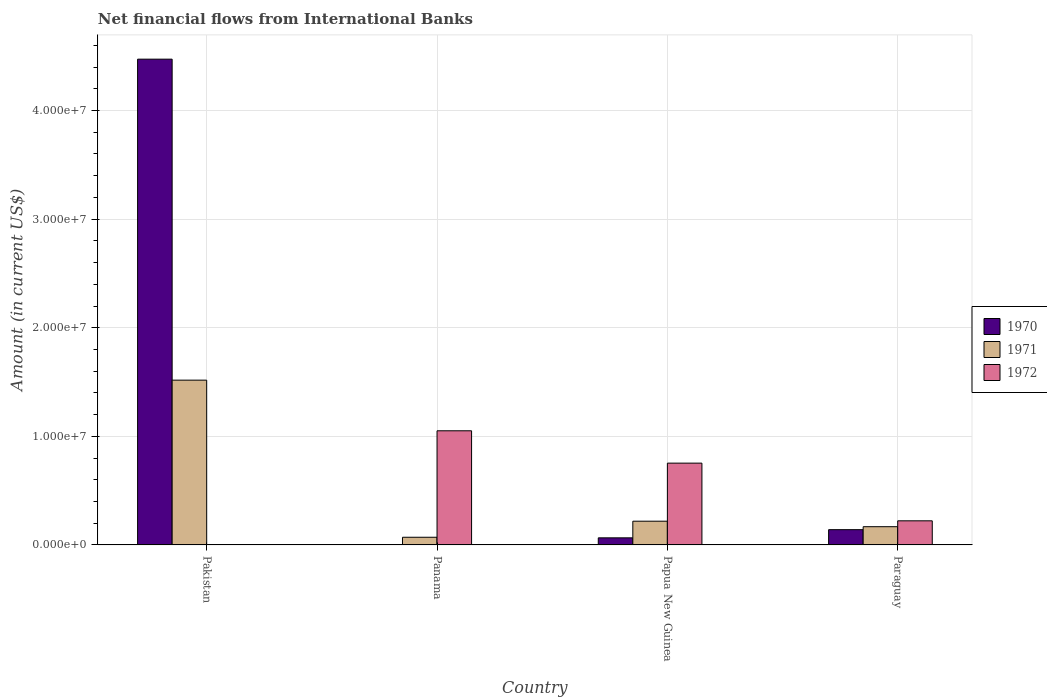Are the number of bars per tick equal to the number of legend labels?
Your answer should be compact. No. How many bars are there on the 2nd tick from the right?
Your answer should be compact. 3. What is the label of the 3rd group of bars from the left?
Your response must be concise. Papua New Guinea. What is the net financial aid flows in 1970 in Paraguay?
Offer a very short reply. 1.41e+06. Across all countries, what is the maximum net financial aid flows in 1971?
Keep it short and to the point. 1.52e+07. Across all countries, what is the minimum net financial aid flows in 1972?
Offer a terse response. 0. In which country was the net financial aid flows in 1972 maximum?
Ensure brevity in your answer.  Panama. What is the total net financial aid flows in 1970 in the graph?
Offer a very short reply. 4.68e+07. What is the difference between the net financial aid flows in 1972 in Panama and that in Paraguay?
Keep it short and to the point. 8.29e+06. What is the difference between the net financial aid flows in 1970 in Pakistan and the net financial aid flows in 1972 in Panama?
Your answer should be compact. 3.42e+07. What is the average net financial aid flows in 1972 per country?
Your answer should be very brief. 5.07e+06. What is the difference between the net financial aid flows of/in 1972 and net financial aid flows of/in 1971 in Panama?
Your response must be concise. 9.80e+06. What is the ratio of the net financial aid flows in 1971 in Pakistan to that in Panama?
Give a very brief answer. 21.46. Is the net financial aid flows in 1970 in Pakistan less than that in Paraguay?
Offer a terse response. No. Is the difference between the net financial aid flows in 1972 in Panama and Papua New Guinea greater than the difference between the net financial aid flows in 1971 in Panama and Papua New Guinea?
Provide a succinct answer. Yes. What is the difference between the highest and the second highest net financial aid flows in 1971?
Offer a very short reply. 1.30e+07. What is the difference between the highest and the lowest net financial aid flows in 1971?
Offer a terse response. 1.45e+07. In how many countries, is the net financial aid flows in 1971 greater than the average net financial aid flows in 1971 taken over all countries?
Provide a short and direct response. 1. Is it the case that in every country, the sum of the net financial aid flows in 1971 and net financial aid flows in 1972 is greater than the net financial aid flows in 1970?
Provide a short and direct response. No. How many bars are there?
Your response must be concise. 10. Are all the bars in the graph horizontal?
Give a very brief answer. No. How many countries are there in the graph?
Offer a very short reply. 4. Are the values on the major ticks of Y-axis written in scientific E-notation?
Provide a short and direct response. Yes. How many legend labels are there?
Provide a short and direct response. 3. How are the legend labels stacked?
Your response must be concise. Vertical. What is the title of the graph?
Provide a succinct answer. Net financial flows from International Banks. Does "1970" appear as one of the legend labels in the graph?
Offer a terse response. Yes. What is the label or title of the X-axis?
Ensure brevity in your answer.  Country. What is the Amount (in current US$) of 1970 in Pakistan?
Offer a terse response. 4.47e+07. What is the Amount (in current US$) of 1971 in Pakistan?
Your answer should be very brief. 1.52e+07. What is the Amount (in current US$) of 1972 in Pakistan?
Your answer should be very brief. 0. What is the Amount (in current US$) in 1971 in Panama?
Offer a very short reply. 7.07e+05. What is the Amount (in current US$) of 1972 in Panama?
Provide a short and direct response. 1.05e+07. What is the Amount (in current US$) in 1970 in Papua New Guinea?
Offer a terse response. 6.53e+05. What is the Amount (in current US$) of 1971 in Papua New Guinea?
Your answer should be very brief. 2.18e+06. What is the Amount (in current US$) in 1972 in Papua New Guinea?
Ensure brevity in your answer.  7.53e+06. What is the Amount (in current US$) in 1970 in Paraguay?
Give a very brief answer. 1.41e+06. What is the Amount (in current US$) of 1971 in Paraguay?
Keep it short and to the point. 1.68e+06. What is the Amount (in current US$) of 1972 in Paraguay?
Give a very brief answer. 2.22e+06. Across all countries, what is the maximum Amount (in current US$) of 1970?
Ensure brevity in your answer.  4.47e+07. Across all countries, what is the maximum Amount (in current US$) of 1971?
Provide a succinct answer. 1.52e+07. Across all countries, what is the maximum Amount (in current US$) of 1972?
Your answer should be very brief. 1.05e+07. Across all countries, what is the minimum Amount (in current US$) of 1971?
Provide a succinct answer. 7.07e+05. Across all countries, what is the minimum Amount (in current US$) of 1972?
Make the answer very short. 0. What is the total Amount (in current US$) of 1970 in the graph?
Provide a succinct answer. 4.68e+07. What is the total Amount (in current US$) in 1971 in the graph?
Give a very brief answer. 1.97e+07. What is the total Amount (in current US$) in 1972 in the graph?
Provide a short and direct response. 2.03e+07. What is the difference between the Amount (in current US$) in 1971 in Pakistan and that in Panama?
Keep it short and to the point. 1.45e+07. What is the difference between the Amount (in current US$) of 1970 in Pakistan and that in Papua New Guinea?
Give a very brief answer. 4.41e+07. What is the difference between the Amount (in current US$) in 1971 in Pakistan and that in Papua New Guinea?
Ensure brevity in your answer.  1.30e+07. What is the difference between the Amount (in current US$) of 1970 in Pakistan and that in Paraguay?
Give a very brief answer. 4.33e+07. What is the difference between the Amount (in current US$) of 1971 in Pakistan and that in Paraguay?
Your answer should be very brief. 1.35e+07. What is the difference between the Amount (in current US$) of 1971 in Panama and that in Papua New Guinea?
Provide a short and direct response. -1.48e+06. What is the difference between the Amount (in current US$) of 1972 in Panama and that in Papua New Guinea?
Keep it short and to the point. 2.98e+06. What is the difference between the Amount (in current US$) of 1971 in Panama and that in Paraguay?
Your response must be concise. -9.72e+05. What is the difference between the Amount (in current US$) in 1972 in Panama and that in Paraguay?
Your answer should be very brief. 8.29e+06. What is the difference between the Amount (in current US$) in 1970 in Papua New Guinea and that in Paraguay?
Your answer should be compact. -7.53e+05. What is the difference between the Amount (in current US$) of 1971 in Papua New Guinea and that in Paraguay?
Give a very brief answer. 5.06e+05. What is the difference between the Amount (in current US$) of 1972 in Papua New Guinea and that in Paraguay?
Offer a terse response. 5.31e+06. What is the difference between the Amount (in current US$) in 1970 in Pakistan and the Amount (in current US$) in 1971 in Panama?
Offer a terse response. 4.40e+07. What is the difference between the Amount (in current US$) in 1970 in Pakistan and the Amount (in current US$) in 1972 in Panama?
Make the answer very short. 3.42e+07. What is the difference between the Amount (in current US$) of 1971 in Pakistan and the Amount (in current US$) of 1972 in Panama?
Offer a terse response. 4.66e+06. What is the difference between the Amount (in current US$) in 1970 in Pakistan and the Amount (in current US$) in 1971 in Papua New Guinea?
Your answer should be compact. 4.25e+07. What is the difference between the Amount (in current US$) in 1970 in Pakistan and the Amount (in current US$) in 1972 in Papua New Guinea?
Offer a terse response. 3.72e+07. What is the difference between the Amount (in current US$) of 1971 in Pakistan and the Amount (in current US$) of 1972 in Papua New Guinea?
Make the answer very short. 7.64e+06. What is the difference between the Amount (in current US$) of 1970 in Pakistan and the Amount (in current US$) of 1971 in Paraguay?
Offer a very short reply. 4.31e+07. What is the difference between the Amount (in current US$) in 1970 in Pakistan and the Amount (in current US$) in 1972 in Paraguay?
Offer a very short reply. 4.25e+07. What is the difference between the Amount (in current US$) of 1971 in Pakistan and the Amount (in current US$) of 1972 in Paraguay?
Make the answer very short. 1.30e+07. What is the difference between the Amount (in current US$) of 1971 in Panama and the Amount (in current US$) of 1972 in Papua New Guinea?
Provide a succinct answer. -6.82e+06. What is the difference between the Amount (in current US$) in 1971 in Panama and the Amount (in current US$) in 1972 in Paraguay?
Make the answer very short. -1.51e+06. What is the difference between the Amount (in current US$) of 1970 in Papua New Guinea and the Amount (in current US$) of 1971 in Paraguay?
Your answer should be compact. -1.03e+06. What is the difference between the Amount (in current US$) of 1970 in Papua New Guinea and the Amount (in current US$) of 1972 in Paraguay?
Offer a very short reply. -1.57e+06. What is the difference between the Amount (in current US$) of 1971 in Papua New Guinea and the Amount (in current US$) of 1972 in Paraguay?
Ensure brevity in your answer.  -3.50e+04. What is the average Amount (in current US$) in 1970 per country?
Give a very brief answer. 1.17e+07. What is the average Amount (in current US$) of 1971 per country?
Your answer should be very brief. 4.94e+06. What is the average Amount (in current US$) of 1972 per country?
Give a very brief answer. 5.07e+06. What is the difference between the Amount (in current US$) in 1970 and Amount (in current US$) in 1971 in Pakistan?
Keep it short and to the point. 2.96e+07. What is the difference between the Amount (in current US$) in 1971 and Amount (in current US$) in 1972 in Panama?
Keep it short and to the point. -9.80e+06. What is the difference between the Amount (in current US$) in 1970 and Amount (in current US$) in 1971 in Papua New Guinea?
Your answer should be very brief. -1.53e+06. What is the difference between the Amount (in current US$) of 1970 and Amount (in current US$) of 1972 in Papua New Guinea?
Provide a succinct answer. -6.88e+06. What is the difference between the Amount (in current US$) in 1971 and Amount (in current US$) in 1972 in Papua New Guinea?
Offer a very short reply. -5.35e+06. What is the difference between the Amount (in current US$) in 1970 and Amount (in current US$) in 1971 in Paraguay?
Provide a short and direct response. -2.73e+05. What is the difference between the Amount (in current US$) in 1970 and Amount (in current US$) in 1972 in Paraguay?
Make the answer very short. -8.14e+05. What is the difference between the Amount (in current US$) of 1971 and Amount (in current US$) of 1972 in Paraguay?
Ensure brevity in your answer.  -5.41e+05. What is the ratio of the Amount (in current US$) in 1971 in Pakistan to that in Panama?
Offer a terse response. 21.46. What is the ratio of the Amount (in current US$) of 1970 in Pakistan to that in Papua New Guinea?
Make the answer very short. 68.5. What is the ratio of the Amount (in current US$) of 1971 in Pakistan to that in Papua New Guinea?
Provide a short and direct response. 6.94. What is the ratio of the Amount (in current US$) of 1970 in Pakistan to that in Paraguay?
Offer a very short reply. 31.81. What is the ratio of the Amount (in current US$) of 1971 in Pakistan to that in Paraguay?
Offer a terse response. 9.04. What is the ratio of the Amount (in current US$) in 1971 in Panama to that in Papua New Guinea?
Your answer should be very brief. 0.32. What is the ratio of the Amount (in current US$) in 1972 in Panama to that in Papua New Guinea?
Offer a very short reply. 1.4. What is the ratio of the Amount (in current US$) in 1971 in Panama to that in Paraguay?
Provide a succinct answer. 0.42. What is the ratio of the Amount (in current US$) in 1972 in Panama to that in Paraguay?
Give a very brief answer. 4.73. What is the ratio of the Amount (in current US$) of 1970 in Papua New Guinea to that in Paraguay?
Provide a short and direct response. 0.46. What is the ratio of the Amount (in current US$) of 1971 in Papua New Guinea to that in Paraguay?
Your answer should be compact. 1.3. What is the ratio of the Amount (in current US$) in 1972 in Papua New Guinea to that in Paraguay?
Your answer should be compact. 3.39. What is the difference between the highest and the second highest Amount (in current US$) in 1970?
Your answer should be compact. 4.33e+07. What is the difference between the highest and the second highest Amount (in current US$) in 1971?
Your answer should be very brief. 1.30e+07. What is the difference between the highest and the second highest Amount (in current US$) in 1972?
Your response must be concise. 2.98e+06. What is the difference between the highest and the lowest Amount (in current US$) in 1970?
Your response must be concise. 4.47e+07. What is the difference between the highest and the lowest Amount (in current US$) of 1971?
Make the answer very short. 1.45e+07. What is the difference between the highest and the lowest Amount (in current US$) of 1972?
Ensure brevity in your answer.  1.05e+07. 